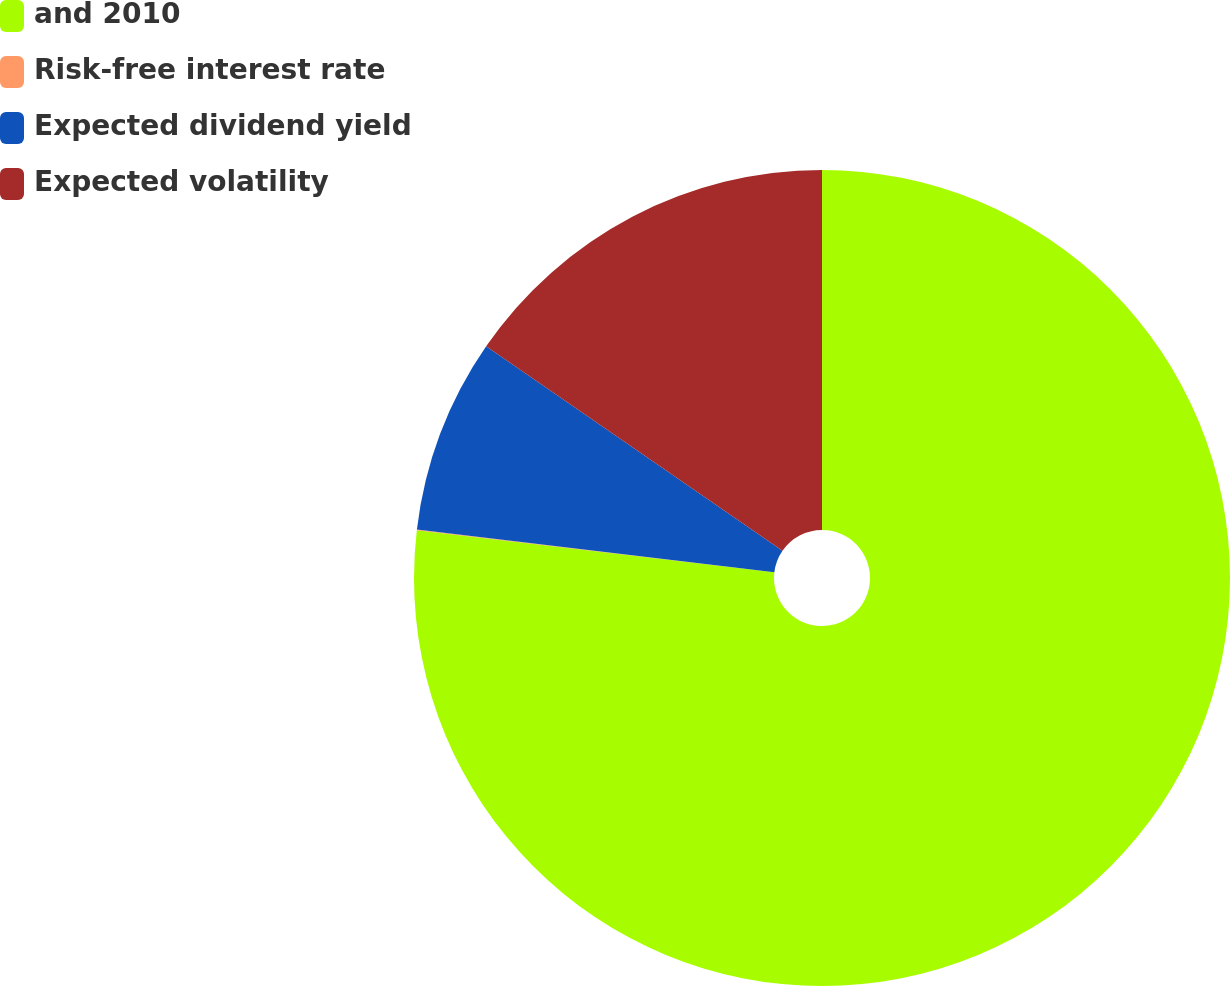Convert chart to OTSL. <chart><loc_0><loc_0><loc_500><loc_500><pie_chart><fcel>and 2010<fcel>Risk-free interest rate<fcel>Expected dividend yield<fcel>Expected volatility<nl><fcel>76.87%<fcel>0.03%<fcel>7.71%<fcel>15.39%<nl></chart> 